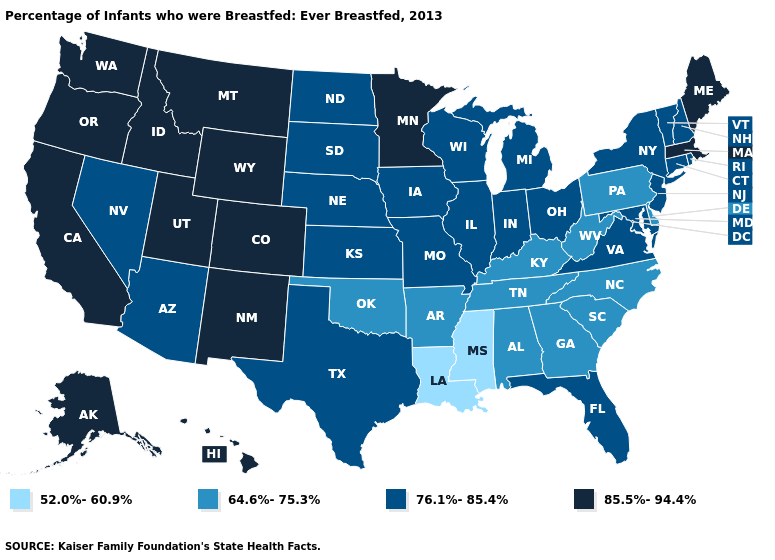What is the lowest value in the West?
Keep it brief. 76.1%-85.4%. Does Missouri have the highest value in the USA?
Quick response, please. No. Name the states that have a value in the range 76.1%-85.4%?
Be succinct. Arizona, Connecticut, Florida, Illinois, Indiana, Iowa, Kansas, Maryland, Michigan, Missouri, Nebraska, Nevada, New Hampshire, New Jersey, New York, North Dakota, Ohio, Rhode Island, South Dakota, Texas, Vermont, Virginia, Wisconsin. Name the states that have a value in the range 64.6%-75.3%?
Write a very short answer. Alabama, Arkansas, Delaware, Georgia, Kentucky, North Carolina, Oklahoma, Pennsylvania, South Carolina, Tennessee, West Virginia. What is the highest value in the West ?
Give a very brief answer. 85.5%-94.4%. What is the value of Michigan?
Be succinct. 76.1%-85.4%. How many symbols are there in the legend?
Be succinct. 4. Among the states that border Alabama , does Florida have the highest value?
Answer briefly. Yes. Does Kentucky have the same value as New Mexico?
Give a very brief answer. No. What is the highest value in states that border Connecticut?
Quick response, please. 85.5%-94.4%. How many symbols are there in the legend?
Be succinct. 4. Name the states that have a value in the range 85.5%-94.4%?
Answer briefly. Alaska, California, Colorado, Hawaii, Idaho, Maine, Massachusetts, Minnesota, Montana, New Mexico, Oregon, Utah, Washington, Wyoming. What is the highest value in the West ?
Quick response, please. 85.5%-94.4%. Is the legend a continuous bar?
Quick response, please. No. 